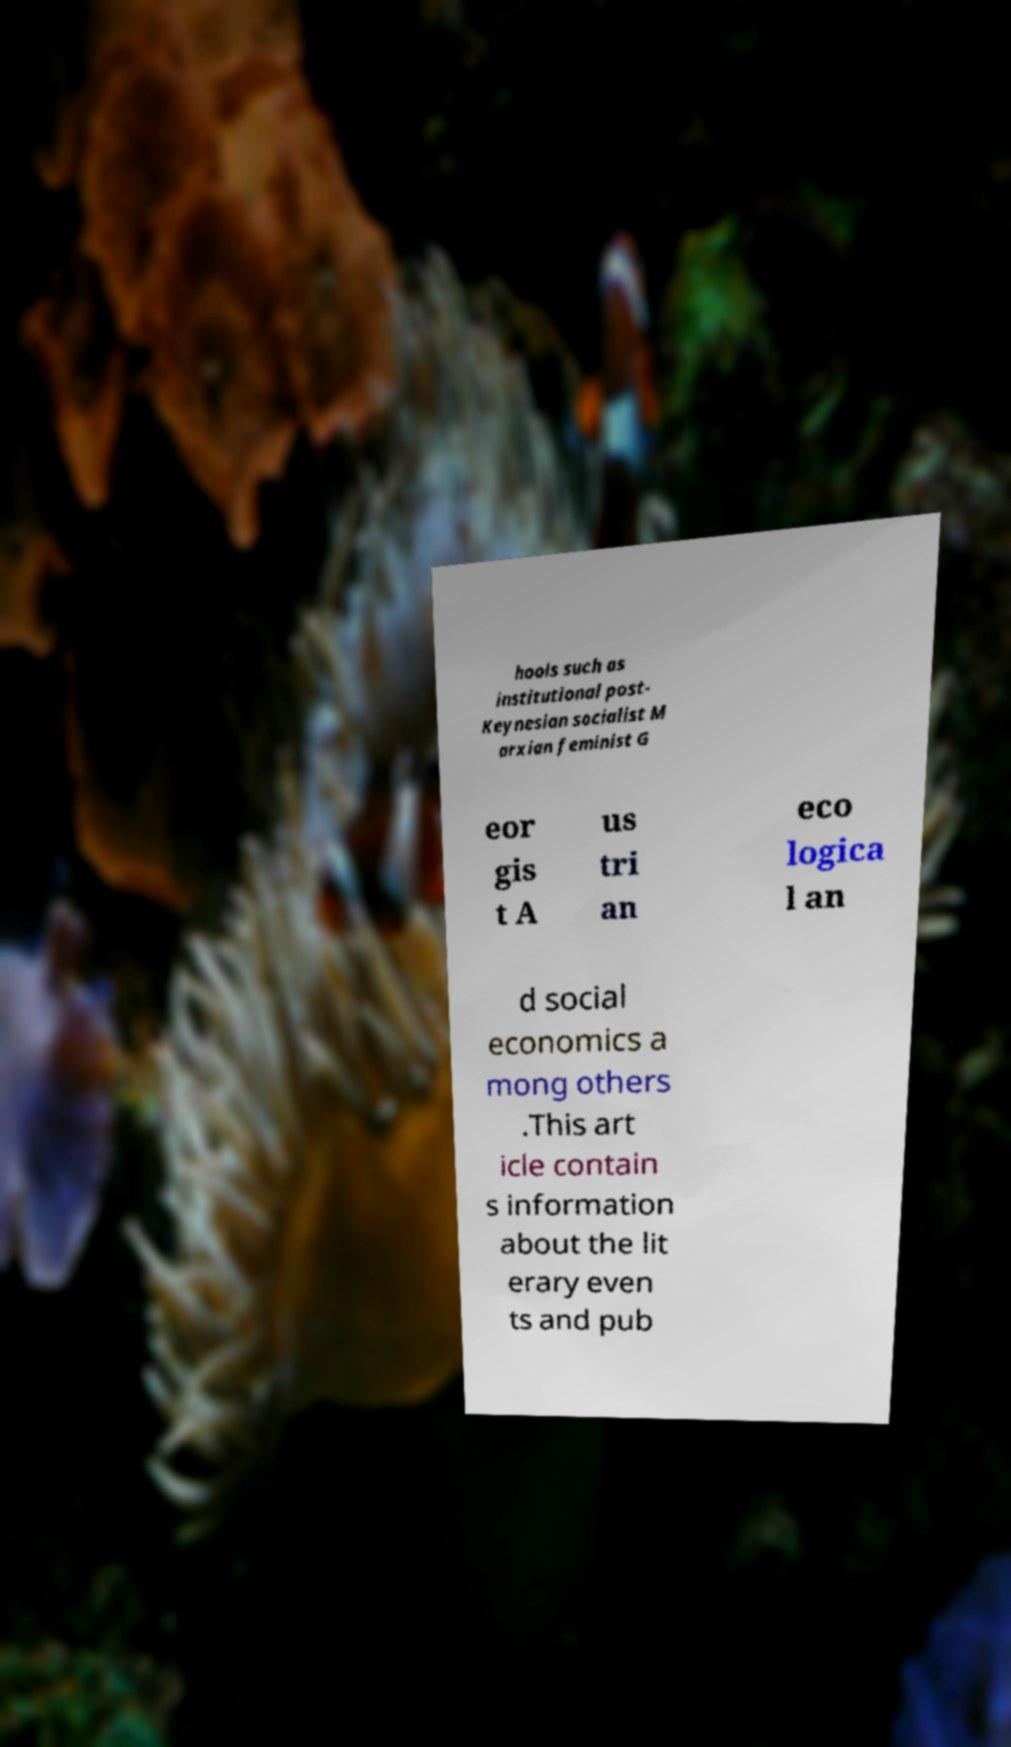Can you read and provide the text displayed in the image?This photo seems to have some interesting text. Can you extract and type it out for me? hools such as institutional post- Keynesian socialist M arxian feminist G eor gis t A us tri an eco logica l an d social economics a mong others .This art icle contain s information about the lit erary even ts and pub 